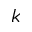Convert formula to latex. <formula><loc_0><loc_0><loc_500><loc_500>k</formula> 